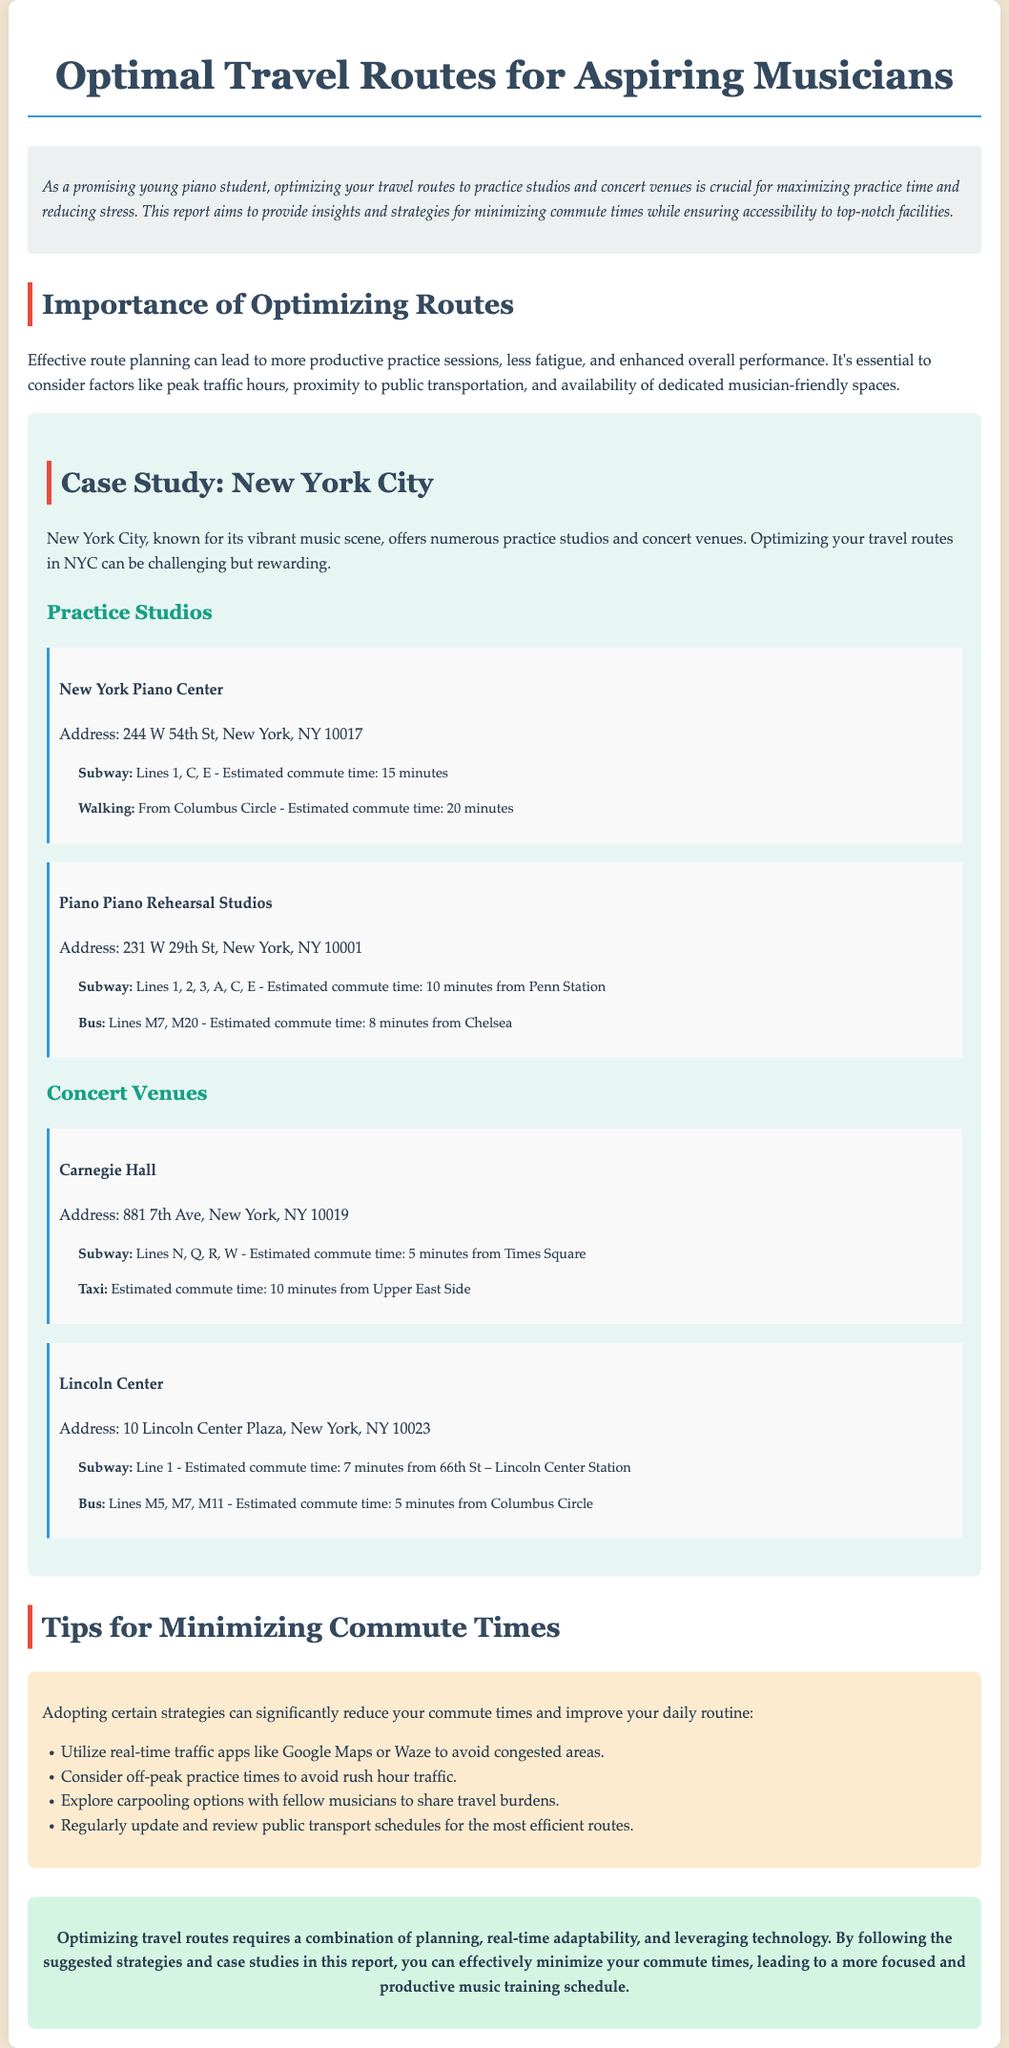what is the title of the report? The title of the report is the main heading found at the top, which gives a clear indication of the content.
Answer: Optimal Travel Routes for Aspiring Musicians what is the estimated subway commute time to New York Piano Center? The document provides specific commute times for different routes to practice studios.
Answer: 15 minutes what are the two subway lines mentioned for commuting to Carnegie Hall? The report lists specific transit options for reaching various concert venues.
Answer: N, Q what is one strategy to minimize commute times? The document suggests various tips to help reduce travel time efficiently.
Answer: Utilize real-time traffic apps what is the address of Lincoln Center? The report contains the addresses of key venues, essential for aspiring musicians to know.
Answer: 10 Lincoln Center Plaza, New York, NY 10023 which subway line has the shortest estimated commute time for Lincoln Center? The report provides estimates for different transport options, which helps in understanding efficiency.
Answer: Line 1 how many practice studios are listed in the case study? The document details specific practice studios within the case study to emphasize optimal planning.
Answer: 2 what is the main purpose of the report? The introduction outlines the fundamental goal of the report to guide its readers about travel.
Answer: Minimizing commute time what type of venues are covered in the case study? The document specifically categorizes various facilities to help musicians plan their travel efficiently.
Answer: Practice studios and concert venues 